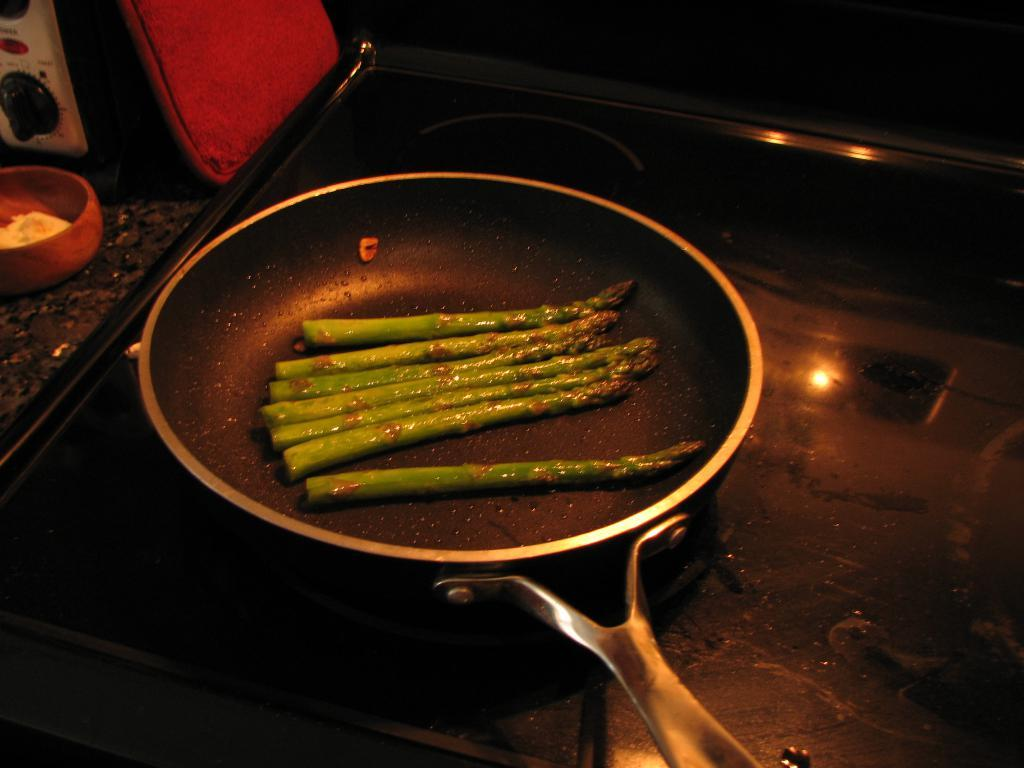What is on the stove in the image? There is a pan on the stove in the image. What is inside the pan? There is a food item in the pan. What can be seen on the left side of the image? There is a bowl with items on the left side. What type of device is present in the image? There is a device in the image. What color stands out in the image? There is a red color thing in the image. What type of feast is being prepared in the image? There is no indication of a feast being prepared in the image; it only shows a pan on the stove with a food item inside. What historical event is depicted in the image? There is no historical event depicted in the image; it shows a pan on the stove, a bowl with items, and a device. 